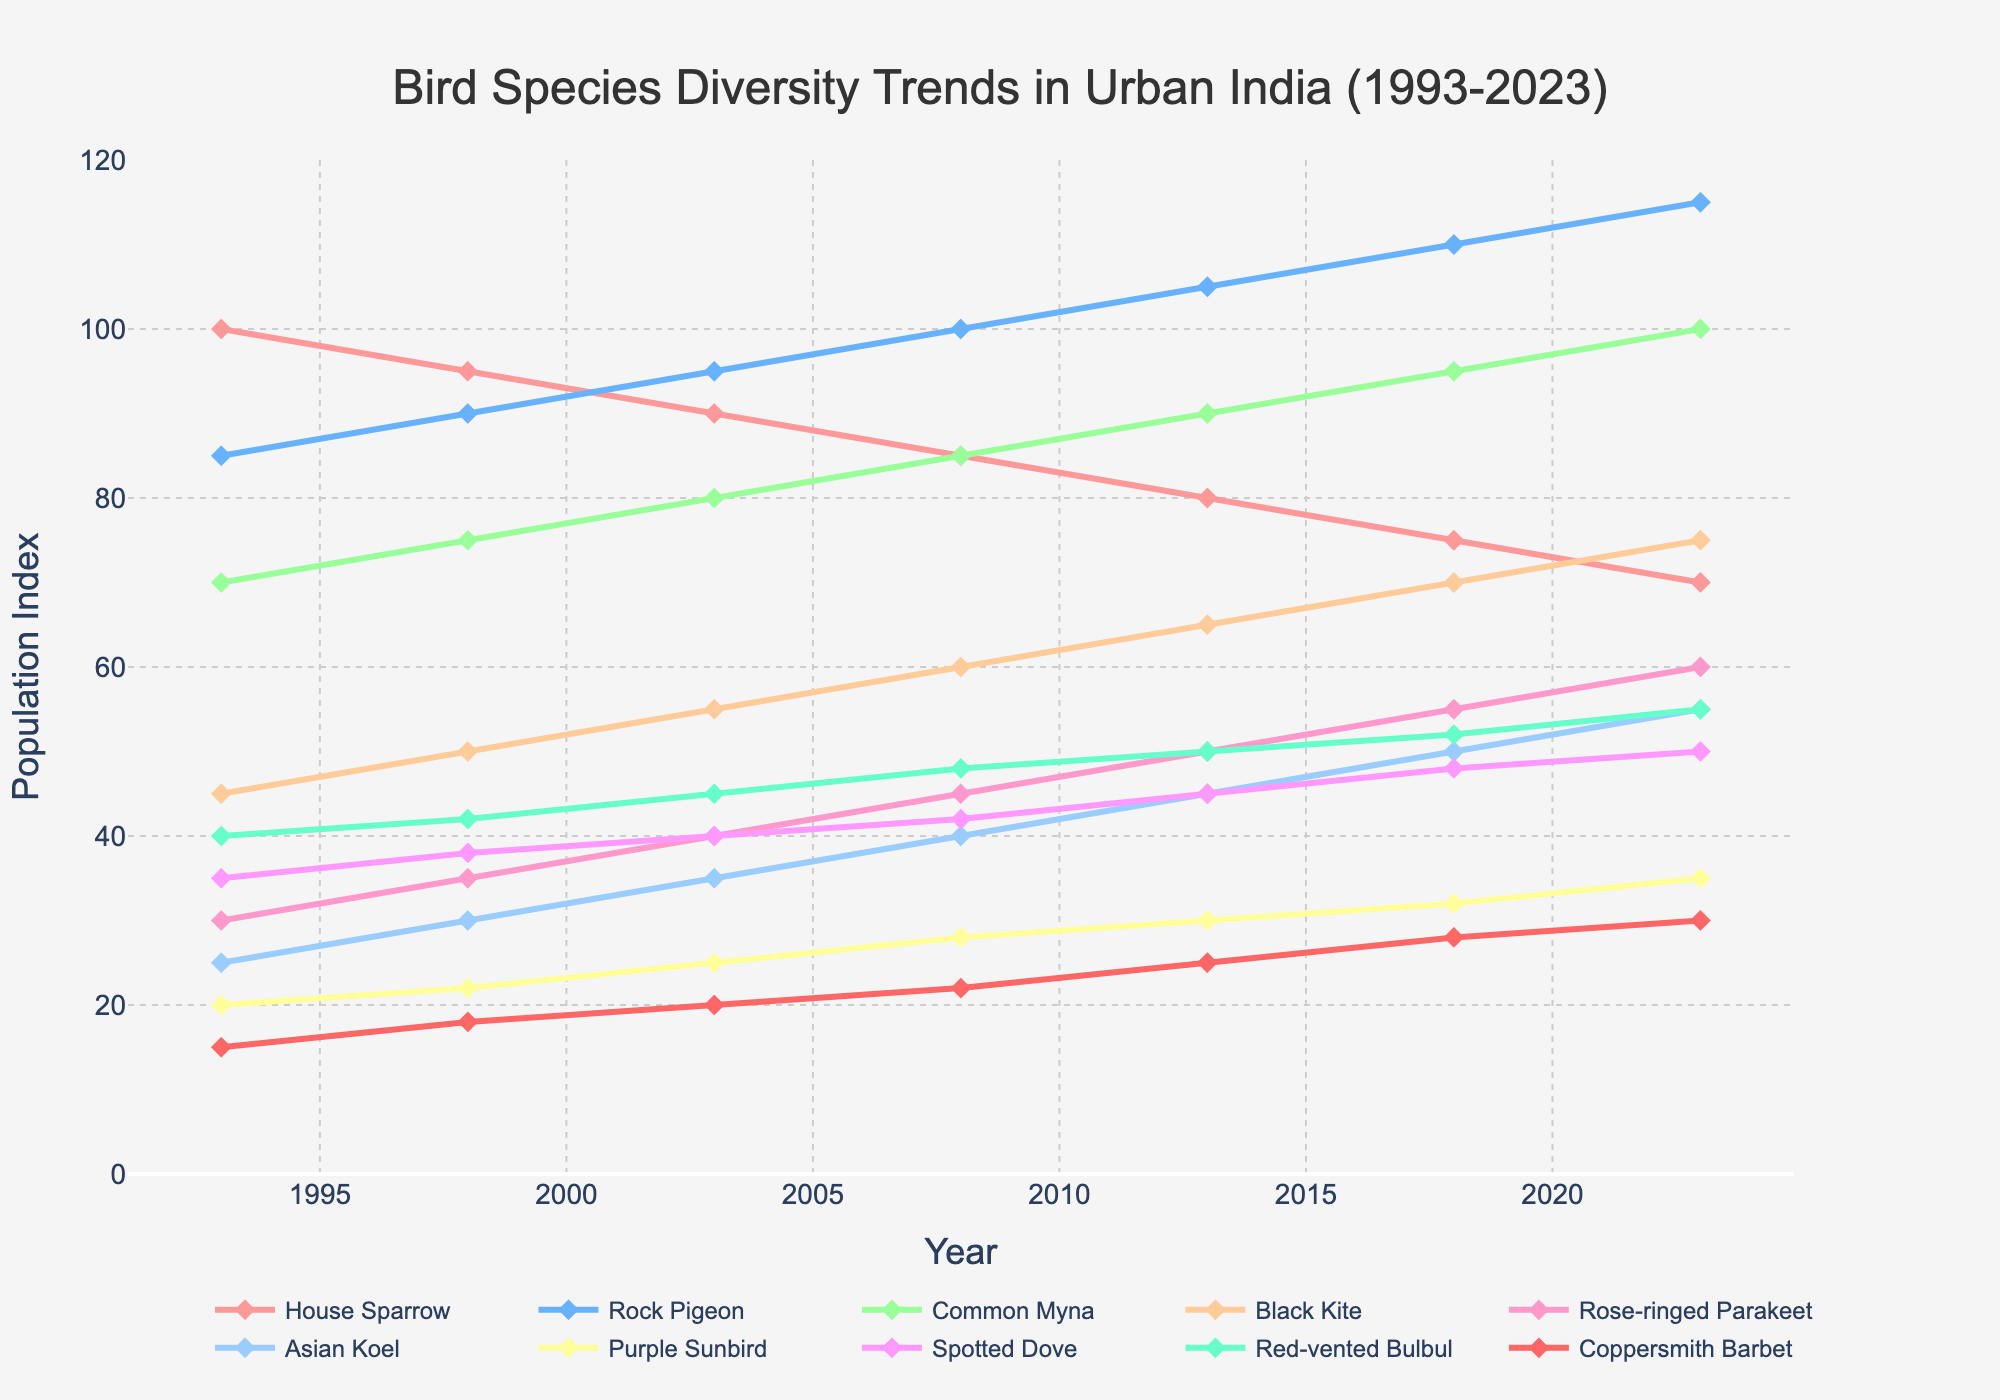Which bird species shows the highest population increase from 1993 to 2023? To determine the highest increase, subtract the values of 1993 from 2023 for each species and compare. House Sparrow: 70-100=-30, Rock Pigeon: 115-85=30, Common Myna: 100-70=30, Black Kite: 75-45=30, Rose-ringed Parakeet: 60-30=30, Asian Koel: 55-25=30, Purple Sunbird: 35-20=15, Spotted Dove: 50-35=15, Red-vented Bulbul: 55-40=15, Coppersmith Barbet: 30-15=15. The Rock Pigeon shows the maximum increase of 30.
Answer: Rock Pigeon Which two bird species have the closest population index values in 2008? Looking at the 2008 data points: House Sparrow: 85, Rock Pigeon: 100, Common Myna: 85, Black Kite: 60, Rose-ringed Parakeet: 45, Asian Koel: 40, Purple Sunbird: 28, Spotted Dove: 42, Red-vented Bulbul: 48, Coppersmith Barbet: 22. House Sparrow and Common Myna both have a population index of 85.
Answer: House Sparrow and Common Myna What is the average population index of the Purple Sunbird from 1993 to 2023? To calculate the average, sum all the values and divide by the number of years. (20+22+25+28+30+32+35)/7 = 192/7 ≈ 27.43.
Answer: 27.43 Which bird species showed a consistent increase in population index over the period from 1993 to 2023? Inspecting each bird species' trend: Rock Pigeon, Common Myna, Black Kite, Rose-ringed Parakeet, Asian Koel show consistent increase across all years.
Answer: Rock Pigeon, Common Myna, Black Kite, Rose-ringed Parakeet, Asian Koel In what year did the House Sparrow's population index drop below 80 for the first time? From the data, House Sparrow's population index is 100 in 1993, 95 in 1998, 90 in 2003, 85 in 2008, 80 in 2013, 75 in 2018, and 70 in 2023. The index drops below 80 in 2018.
Answer: 2018 What is the total population index for all bird species combined in 2023? Sum the population indices of all species in 2023: 70+115+100+75+60+55+35+50+55+30 = 645.
Answer: 645 How did the population index of the Black Kite change between 1998 and 2013? Black Kite's index in 1998 is 50 and in 2013 is 65. The change is 65-50 = 15.
Answer: 15 Which bird species has the least population index in 2023? From the data in 2023: House Sparrow: 70, Rock Pigeon: 115, Common Myna: 100, Black Kite: 75, Rose-ringed Parakeet: 60, Asian Koel: 55, Purple Sunbird: 35, Spotted Dove: 50, Red-vented Bulbul: 55, Coppersmith Barbet: 30. Coppersmith Barbet has the least population index of 30.
Answer: Coppersmith Barbet Which bird species had the greatest population index in any single year during this period? Inspecting the highest value for each year: House Sparrow: 100, Rock Pigeon: 115, Common Myna: 100, Black Kite: 75, Rose-ringed Parakeet: 60, Asian Koel: 55, Purple Sunbird: 35, Spotted Dove: 50, Red-vented Bulbul: 55, Coppersmith Barbet: 30. The highest value across the years is for the Rock Pigeon in 2023 with 115.
Answer: Rock Pigeon in 2023 Which year shows the highest population index for the Asian Koel? The population index for the Asian Koel over the years is: 1993: 25, 1998: 30, 2003: 35, 2008: 40, 2013: 45, 2018: 50, 2023: 55. The highest value is in 2023 with an index of 55.
Answer: 2023 